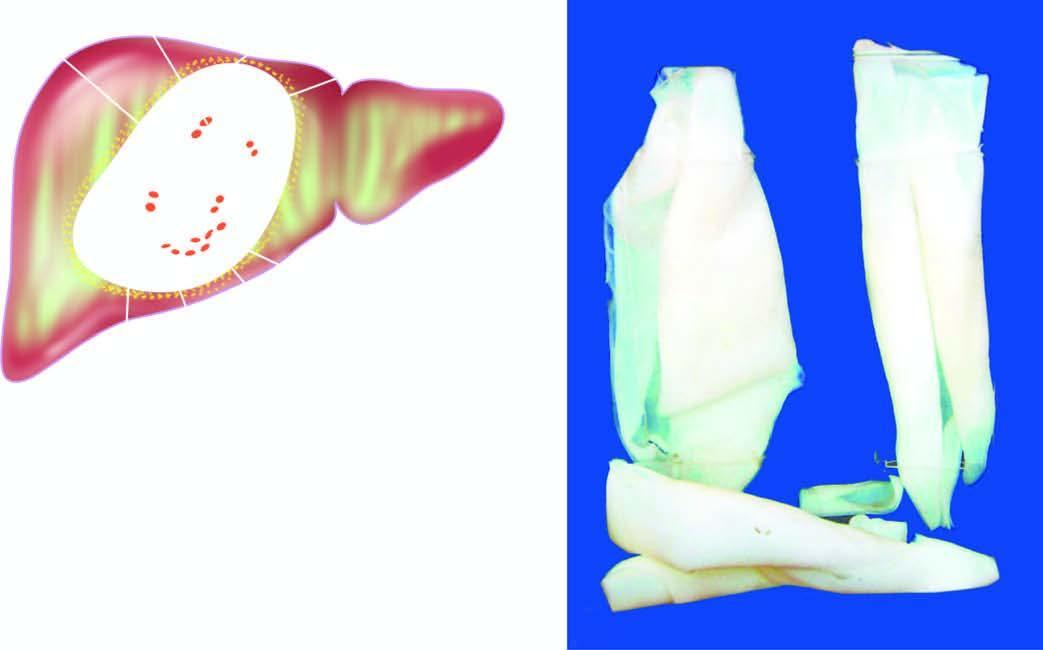what is composed of whitish membrane resembling the membrane of a hard boiled egg?
Answer the question using a single word or phrase. Cyst wall 